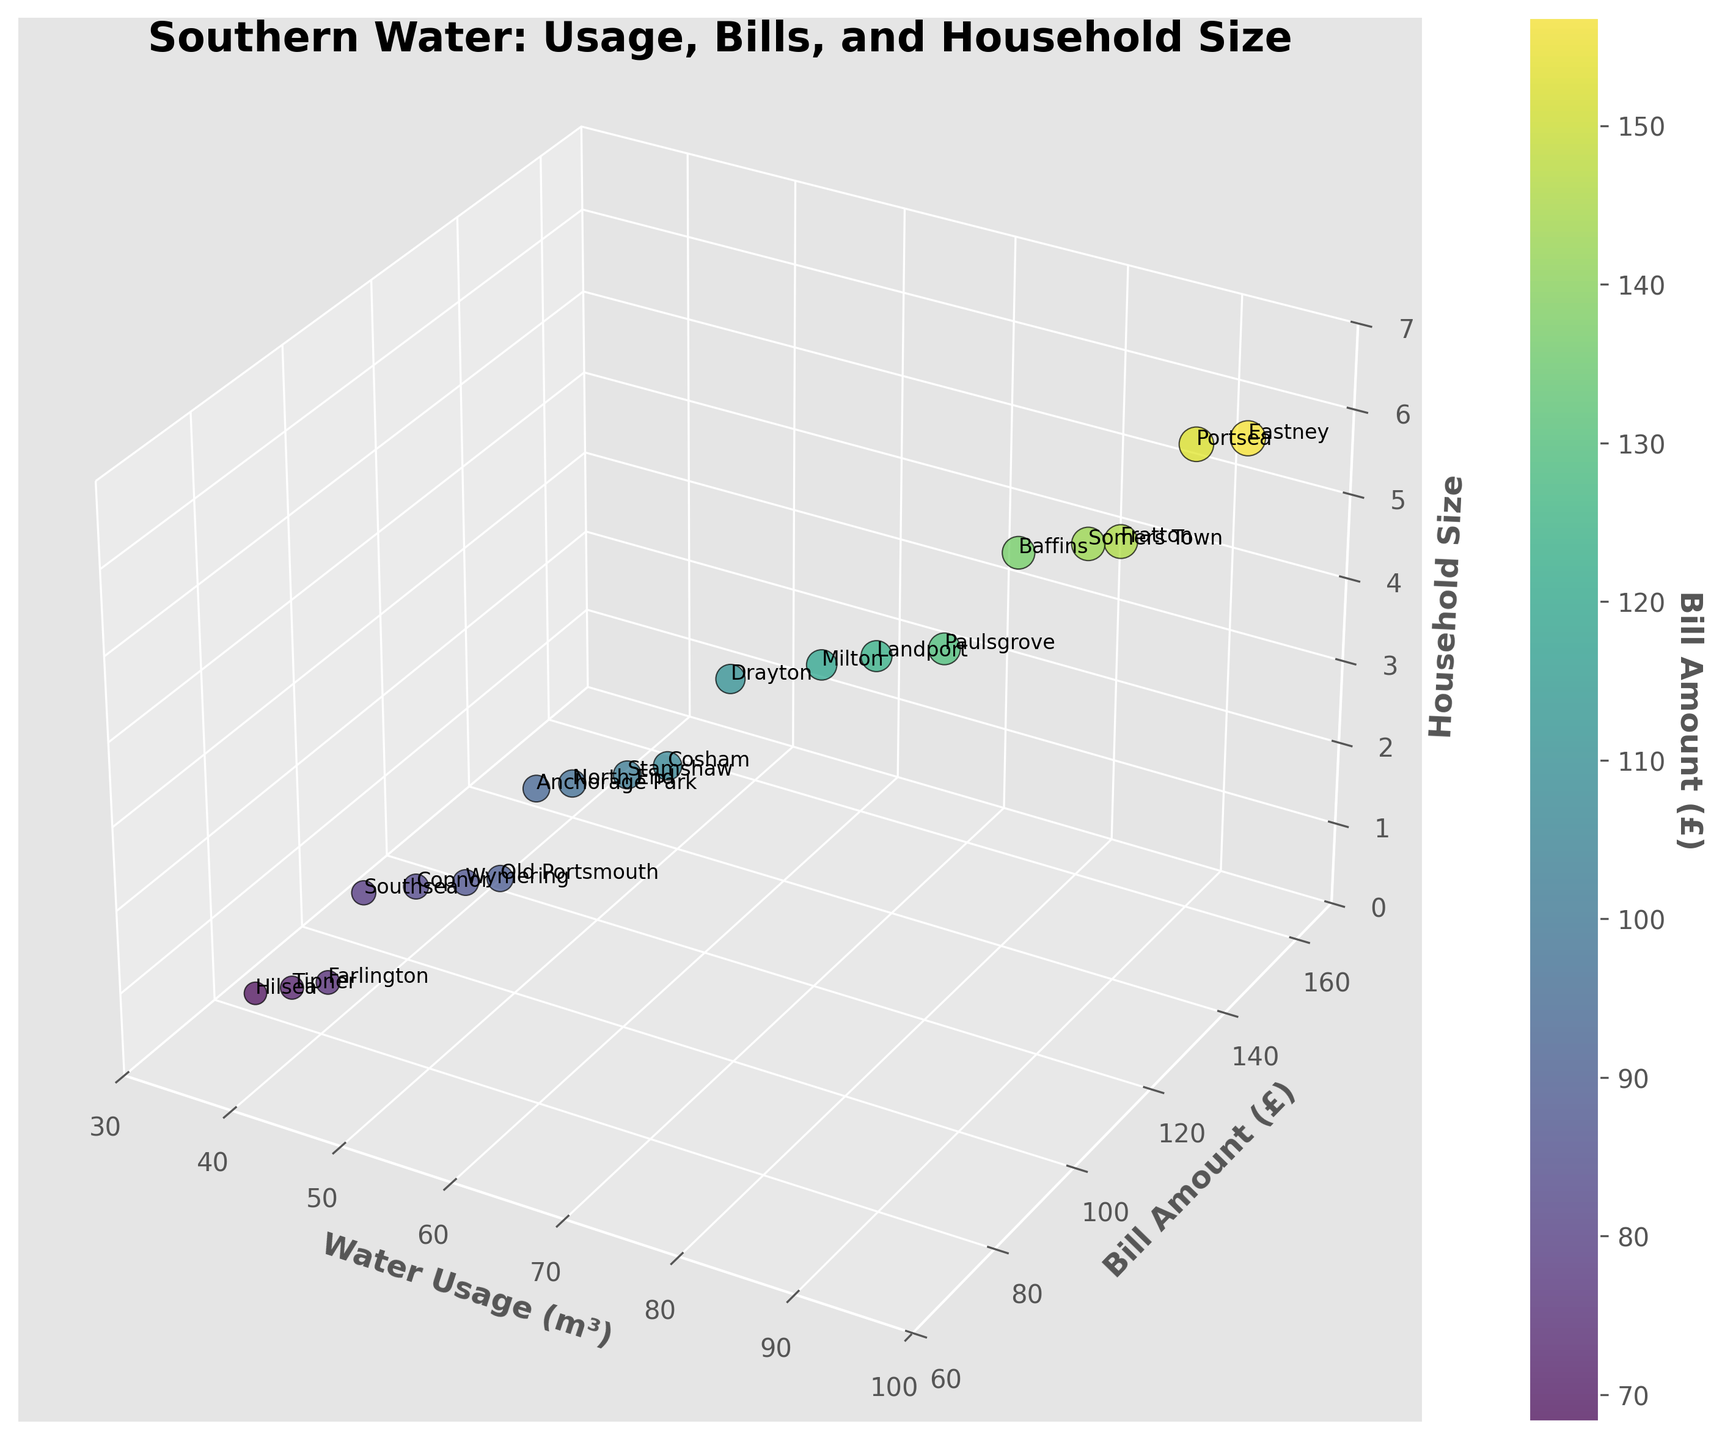What's the title of the figure? The title is placed at the top of the figure, which is "Southern Water: Usage, Bills, and Household Size". You can read it directly from the top section of the visual.
Answer: Southern Water: Usage, Bills, and Household Size What are the axes labels in the plot? The axis labels can be read directly from the plot. The x-axis is labeled "Water Usage (m³)", the y-axis is labeled "Bill Amount (£)", and the z-axis is labeled "Household Size".
Answer: Water Usage (m³), Bill Amount (£), Household Size Which neighborhood has the highest water usage? Look for the data point that is farthest along the x-axis (Water Usage) in the plot. The highest value on the x-axis corresponds to "Eastney" in this dataset.
Answer: Eastney Which neighborhood has the smallest household size? Find the points that are lowest on the z-axis (Household Size). Multiple neighborhoods have a household size of 1, including "Hilsea", "Farlington", and "Tipner".
Answer: Hilsea, Farlington, Tipner What is the relationship between bill amount and water usage for Old Portsmouth? Locate the data point labeled "Old Portsmouth". Follow its coordinates to understand the relationship along the axes. Old Portsmouth is shown with a water usage of 53 m³ and a bill amount of £89.60.
Answer: 53 m³, £89.60 Which neighborhood has the highest bill, and what is the water usage for that neighborhood? Find the data point that is highest on the y-axis (Bill Amount). The highest bill is from "Eastney" with a bill amount of £156.80 and a water usage of 95 m³.
Answer: Eastney, 95 m³ How many neighborhoods have a household size of 2? Count the number of data points plotted at a z-axis (Household Size) value of 2. They are for "Southsea", "Old Portsmouth", "Copnor", and "Wymering".
Answer: 4 Which neighborhood has a household size of 6 and what are their water usage and bill amount? Find the points with a z-axis value of 6. "Eastney" and "Portsea" are the neighborhoods, with water usage of 95 m³ and 92 m³, and bills of £156.80 and £152.30 respectively.
Answer: Eastney: 95 m³, £156.80; Portsea: 92 m³, £152.30 Compare the water usage between Cosham and Fratton and determine which one is higher. Locate the data points labeled "Cosham" and "Fratton". Compare their positions on the x-axis. Cosham has 62 m³ and Fratton has 88 m³, thus Fratton is higher.
Answer: Fratton On average, do neighborhoods with a household size of 4 use more water than neighborhoods with a household size of 2? Calculate the average water usage for household sizes of 4 and 2. Household size 4: (71 + 66 + 78 + 74) / 4 = 72.25 m³. Household size 2: (45 + 53 + 48 + 51) / 4 = 49.25 m³. Comparing these averages, neighborhoods with a household size of 4 use more water.
Answer: Yes, 72.25 m³ vs 49.25 m³ 